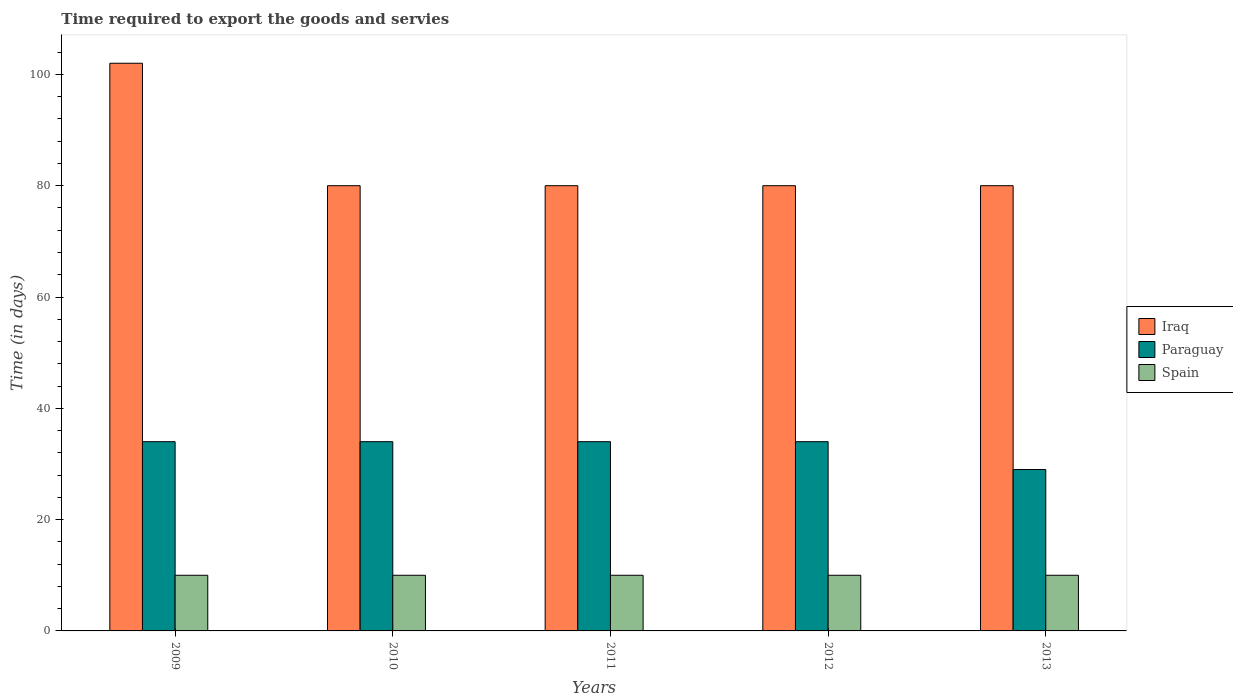How many groups of bars are there?
Your response must be concise. 5. How many bars are there on the 3rd tick from the left?
Ensure brevity in your answer.  3. How many bars are there on the 1st tick from the right?
Offer a very short reply. 3. In how many cases, is the number of bars for a given year not equal to the number of legend labels?
Your response must be concise. 0. What is the number of days required to export the goods and services in Paraguay in 2010?
Make the answer very short. 34. Across all years, what is the maximum number of days required to export the goods and services in Iraq?
Offer a very short reply. 102. Across all years, what is the minimum number of days required to export the goods and services in Iraq?
Give a very brief answer. 80. In which year was the number of days required to export the goods and services in Iraq minimum?
Ensure brevity in your answer.  2010. What is the total number of days required to export the goods and services in Paraguay in the graph?
Ensure brevity in your answer.  165. What is the difference between the number of days required to export the goods and services in Spain in 2009 and the number of days required to export the goods and services in Iraq in 2012?
Your answer should be very brief. -70. In the year 2011, what is the difference between the number of days required to export the goods and services in Paraguay and number of days required to export the goods and services in Spain?
Your answer should be very brief. 24. What is the ratio of the number of days required to export the goods and services in Iraq in 2009 to that in 2013?
Your answer should be very brief. 1.27. Is the number of days required to export the goods and services in Spain in 2009 less than that in 2013?
Your answer should be very brief. No. Is the difference between the number of days required to export the goods and services in Paraguay in 2009 and 2012 greater than the difference between the number of days required to export the goods and services in Spain in 2009 and 2012?
Keep it short and to the point. No. What is the difference between the highest and the lowest number of days required to export the goods and services in Spain?
Provide a short and direct response. 0. Is the sum of the number of days required to export the goods and services in Iraq in 2009 and 2010 greater than the maximum number of days required to export the goods and services in Spain across all years?
Provide a succinct answer. Yes. What does the 3rd bar from the left in 2010 represents?
Give a very brief answer. Spain. What does the 3rd bar from the right in 2010 represents?
Your answer should be compact. Iraq. Are all the bars in the graph horizontal?
Provide a short and direct response. No. How many years are there in the graph?
Make the answer very short. 5. Are the values on the major ticks of Y-axis written in scientific E-notation?
Offer a terse response. No. How many legend labels are there?
Offer a very short reply. 3. How are the legend labels stacked?
Ensure brevity in your answer.  Vertical. What is the title of the graph?
Offer a terse response. Time required to export the goods and servies. Does "Heavily indebted poor countries" appear as one of the legend labels in the graph?
Your answer should be compact. No. What is the label or title of the Y-axis?
Your response must be concise. Time (in days). What is the Time (in days) in Iraq in 2009?
Provide a short and direct response. 102. What is the Time (in days) of Paraguay in 2009?
Your answer should be compact. 34. What is the Time (in days) of Iraq in 2010?
Keep it short and to the point. 80. What is the Time (in days) in Spain in 2010?
Ensure brevity in your answer.  10. What is the Time (in days) of Paraguay in 2011?
Provide a short and direct response. 34. What is the Time (in days) of Iraq in 2012?
Offer a very short reply. 80. What is the Time (in days) in Paraguay in 2012?
Ensure brevity in your answer.  34. What is the Time (in days) in Iraq in 2013?
Keep it short and to the point. 80. Across all years, what is the maximum Time (in days) of Iraq?
Offer a terse response. 102. Across all years, what is the maximum Time (in days) in Paraguay?
Provide a short and direct response. 34. Across all years, what is the minimum Time (in days) in Iraq?
Keep it short and to the point. 80. Across all years, what is the minimum Time (in days) in Paraguay?
Make the answer very short. 29. What is the total Time (in days) in Iraq in the graph?
Provide a succinct answer. 422. What is the total Time (in days) of Paraguay in the graph?
Offer a terse response. 165. What is the difference between the Time (in days) in Iraq in 2009 and that in 2010?
Offer a very short reply. 22. What is the difference between the Time (in days) in Spain in 2009 and that in 2010?
Provide a succinct answer. 0. What is the difference between the Time (in days) of Spain in 2009 and that in 2011?
Your answer should be very brief. 0. What is the difference between the Time (in days) of Spain in 2009 and that in 2012?
Your answer should be compact. 0. What is the difference between the Time (in days) of Spain in 2009 and that in 2013?
Your answer should be very brief. 0. What is the difference between the Time (in days) in Paraguay in 2010 and that in 2011?
Ensure brevity in your answer.  0. What is the difference between the Time (in days) of Spain in 2010 and that in 2011?
Make the answer very short. 0. What is the difference between the Time (in days) in Paraguay in 2010 and that in 2012?
Give a very brief answer. 0. What is the difference between the Time (in days) of Spain in 2011 and that in 2012?
Your answer should be very brief. 0. What is the difference between the Time (in days) in Iraq in 2011 and that in 2013?
Offer a very short reply. 0. What is the difference between the Time (in days) of Iraq in 2009 and the Time (in days) of Spain in 2010?
Make the answer very short. 92. What is the difference between the Time (in days) in Iraq in 2009 and the Time (in days) in Spain in 2011?
Make the answer very short. 92. What is the difference between the Time (in days) of Paraguay in 2009 and the Time (in days) of Spain in 2011?
Offer a very short reply. 24. What is the difference between the Time (in days) of Iraq in 2009 and the Time (in days) of Spain in 2012?
Provide a short and direct response. 92. What is the difference between the Time (in days) of Iraq in 2009 and the Time (in days) of Spain in 2013?
Your response must be concise. 92. What is the difference between the Time (in days) in Iraq in 2010 and the Time (in days) in Paraguay in 2011?
Your response must be concise. 46. What is the difference between the Time (in days) in Iraq in 2010 and the Time (in days) in Spain in 2011?
Offer a very short reply. 70. What is the difference between the Time (in days) of Paraguay in 2010 and the Time (in days) of Spain in 2011?
Your response must be concise. 24. What is the difference between the Time (in days) of Iraq in 2010 and the Time (in days) of Spain in 2012?
Provide a succinct answer. 70. What is the difference between the Time (in days) of Paraguay in 2011 and the Time (in days) of Spain in 2012?
Provide a short and direct response. 24. What is the difference between the Time (in days) in Iraq in 2011 and the Time (in days) in Paraguay in 2013?
Your answer should be very brief. 51. What is the difference between the Time (in days) of Iraq in 2011 and the Time (in days) of Spain in 2013?
Offer a terse response. 70. What is the difference between the Time (in days) of Paraguay in 2011 and the Time (in days) of Spain in 2013?
Keep it short and to the point. 24. What is the difference between the Time (in days) of Iraq in 2012 and the Time (in days) of Spain in 2013?
Ensure brevity in your answer.  70. What is the average Time (in days) of Iraq per year?
Offer a very short reply. 84.4. What is the average Time (in days) in Paraguay per year?
Give a very brief answer. 33. What is the average Time (in days) of Spain per year?
Provide a short and direct response. 10. In the year 2009, what is the difference between the Time (in days) of Iraq and Time (in days) of Paraguay?
Your answer should be compact. 68. In the year 2009, what is the difference between the Time (in days) in Iraq and Time (in days) in Spain?
Offer a terse response. 92. In the year 2009, what is the difference between the Time (in days) in Paraguay and Time (in days) in Spain?
Make the answer very short. 24. In the year 2010, what is the difference between the Time (in days) in Iraq and Time (in days) in Paraguay?
Ensure brevity in your answer.  46. In the year 2010, what is the difference between the Time (in days) in Paraguay and Time (in days) in Spain?
Your answer should be compact. 24. In the year 2012, what is the difference between the Time (in days) of Iraq and Time (in days) of Paraguay?
Make the answer very short. 46. In the year 2012, what is the difference between the Time (in days) of Iraq and Time (in days) of Spain?
Make the answer very short. 70. In the year 2013, what is the difference between the Time (in days) in Iraq and Time (in days) in Paraguay?
Provide a short and direct response. 51. In the year 2013, what is the difference between the Time (in days) of Paraguay and Time (in days) of Spain?
Provide a short and direct response. 19. What is the ratio of the Time (in days) in Iraq in 2009 to that in 2010?
Offer a very short reply. 1.27. What is the ratio of the Time (in days) in Iraq in 2009 to that in 2011?
Provide a short and direct response. 1.27. What is the ratio of the Time (in days) of Spain in 2009 to that in 2011?
Your response must be concise. 1. What is the ratio of the Time (in days) in Iraq in 2009 to that in 2012?
Your response must be concise. 1.27. What is the ratio of the Time (in days) in Spain in 2009 to that in 2012?
Provide a succinct answer. 1. What is the ratio of the Time (in days) in Iraq in 2009 to that in 2013?
Offer a very short reply. 1.27. What is the ratio of the Time (in days) of Paraguay in 2009 to that in 2013?
Your answer should be very brief. 1.17. What is the ratio of the Time (in days) of Paraguay in 2010 to that in 2011?
Your answer should be very brief. 1. What is the ratio of the Time (in days) of Iraq in 2010 to that in 2012?
Keep it short and to the point. 1. What is the ratio of the Time (in days) in Paraguay in 2010 to that in 2012?
Give a very brief answer. 1. What is the ratio of the Time (in days) of Spain in 2010 to that in 2012?
Provide a succinct answer. 1. What is the ratio of the Time (in days) of Paraguay in 2010 to that in 2013?
Offer a terse response. 1.17. What is the ratio of the Time (in days) in Iraq in 2011 to that in 2013?
Offer a very short reply. 1. What is the ratio of the Time (in days) of Paraguay in 2011 to that in 2013?
Make the answer very short. 1.17. What is the ratio of the Time (in days) in Paraguay in 2012 to that in 2013?
Provide a succinct answer. 1.17. What is the difference between the highest and the second highest Time (in days) of Iraq?
Keep it short and to the point. 22. What is the difference between the highest and the second highest Time (in days) in Paraguay?
Provide a short and direct response. 0. 